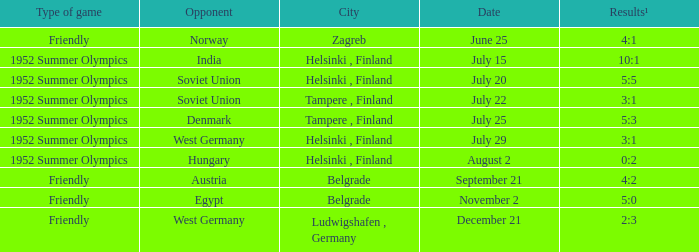What is the Results¹ that was a friendly game and played on June 25? 4:1. 